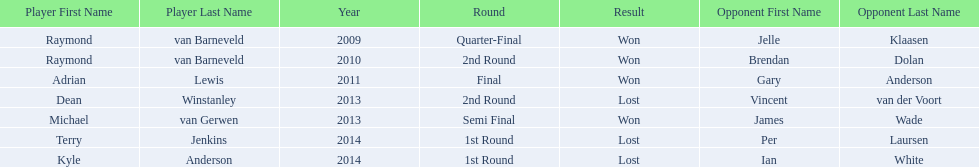What are all the years? 2009, 2010, 2011, 2013, 2013, 2014, 2014. Of these, which ones are 2014? 2014, 2014. Of these dates which one is associated with a player other than kyle anderson? 2014. What is the player name associated with this year? Terry Jenkins. 